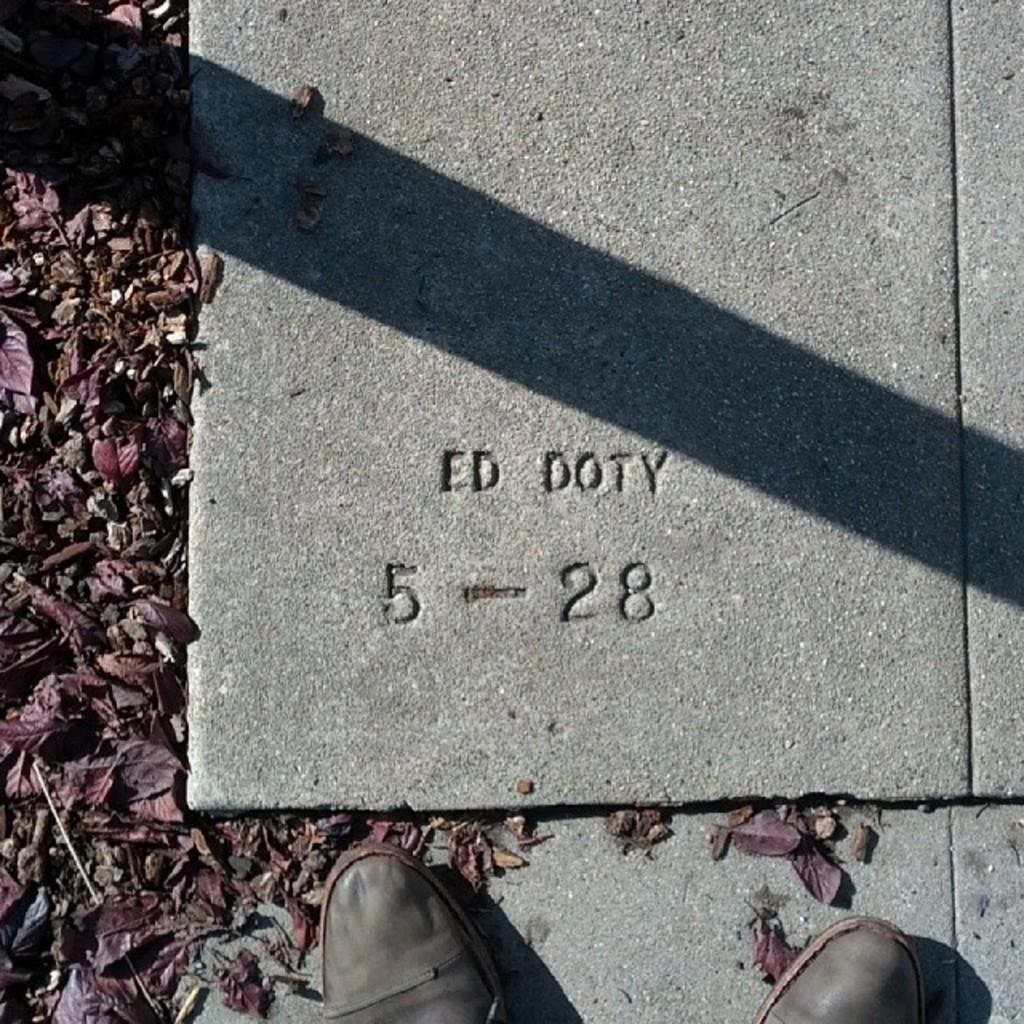What type of footwear is visible in the image? There is a pair of shoes in the image. What can be seen on the tile in the image? There is text on the tile in the image. What type of natural material is scattered on the ground in the image? Shredded leaves are present on the ground in the image. How many eggs are visible in the image? There are no eggs present in the image. What type of feather can be seen on the shoes in the image? There is no feather present on the shoes in the image. 